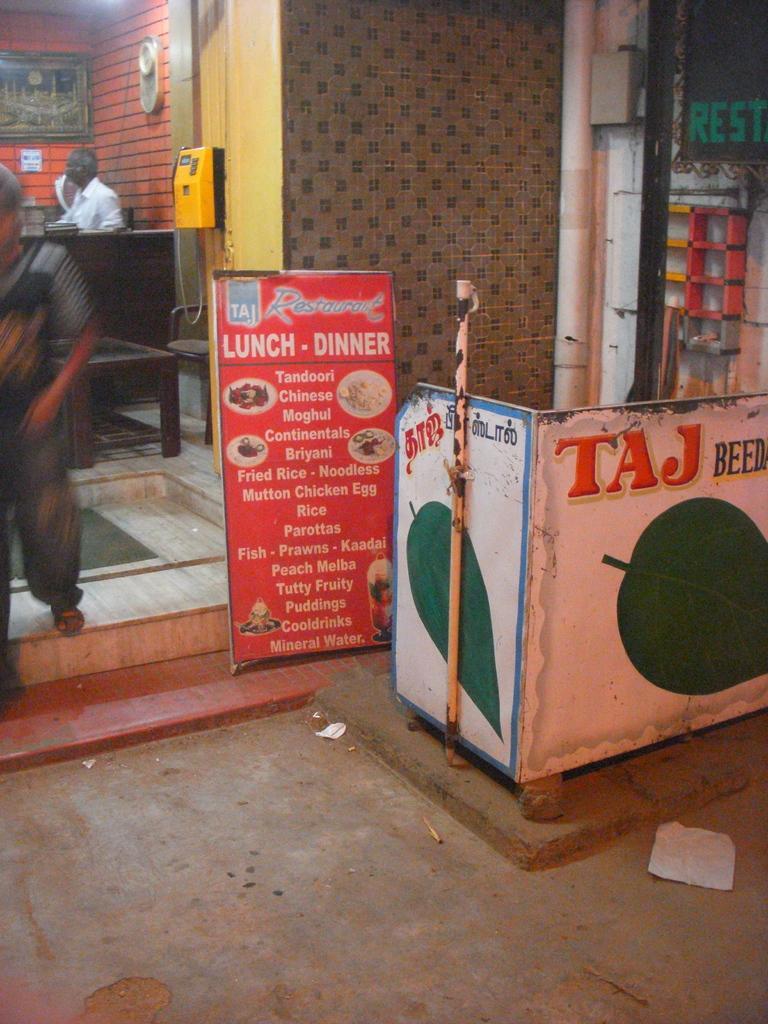Describe this image in one or two sentences. On the right side of the image we can see a stall and a board. On the left there is a man sitting and we can see tables. There is a telephone. In the background there are frames placed on the wall and we can see a man walking. 